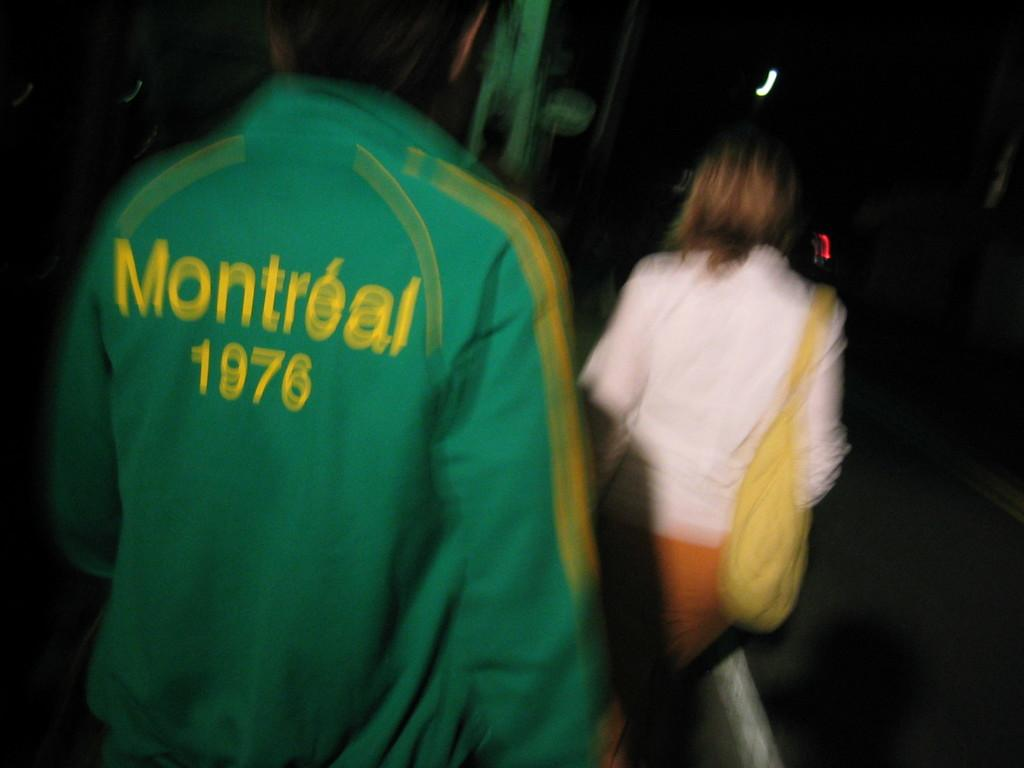<image>
Relay a brief, clear account of the picture shown. A green jacket with yellow lettering that says. Montreal 1976. 